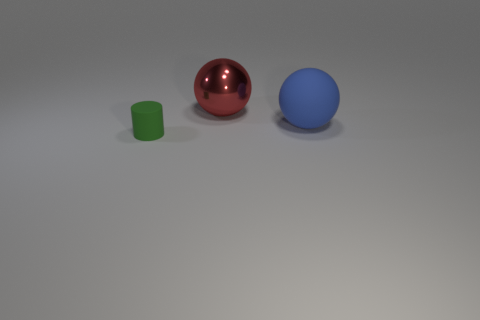Subtract all red balls. How many balls are left? 1 Subtract 1 spheres. How many spheres are left? 1 Subtract all blue cylinders. How many blue spheres are left? 1 Add 2 red blocks. How many objects exist? 5 Subtract all spheres. How many objects are left? 1 Subtract all cyan cylinders. Subtract all cyan cubes. How many cylinders are left? 1 Subtract all rubber spheres. Subtract all big red balls. How many objects are left? 1 Add 3 large blue matte balls. How many large blue matte balls are left? 4 Add 3 cyan metallic cubes. How many cyan metallic cubes exist? 3 Subtract 0 green spheres. How many objects are left? 3 